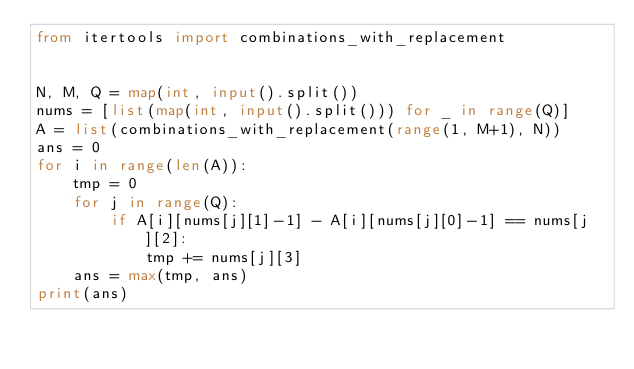<code> <loc_0><loc_0><loc_500><loc_500><_Python_>from itertools import combinations_with_replacement


N, M, Q = map(int, input().split())
nums = [list(map(int, input().split())) for _ in range(Q)]
A = list(combinations_with_replacement(range(1, M+1), N))
ans = 0
for i in range(len(A)):
    tmp = 0
    for j in range(Q):
        if A[i][nums[j][1]-1] - A[i][nums[j][0]-1] == nums[j][2]:
            tmp += nums[j][3]
    ans = max(tmp, ans)
print(ans)</code> 